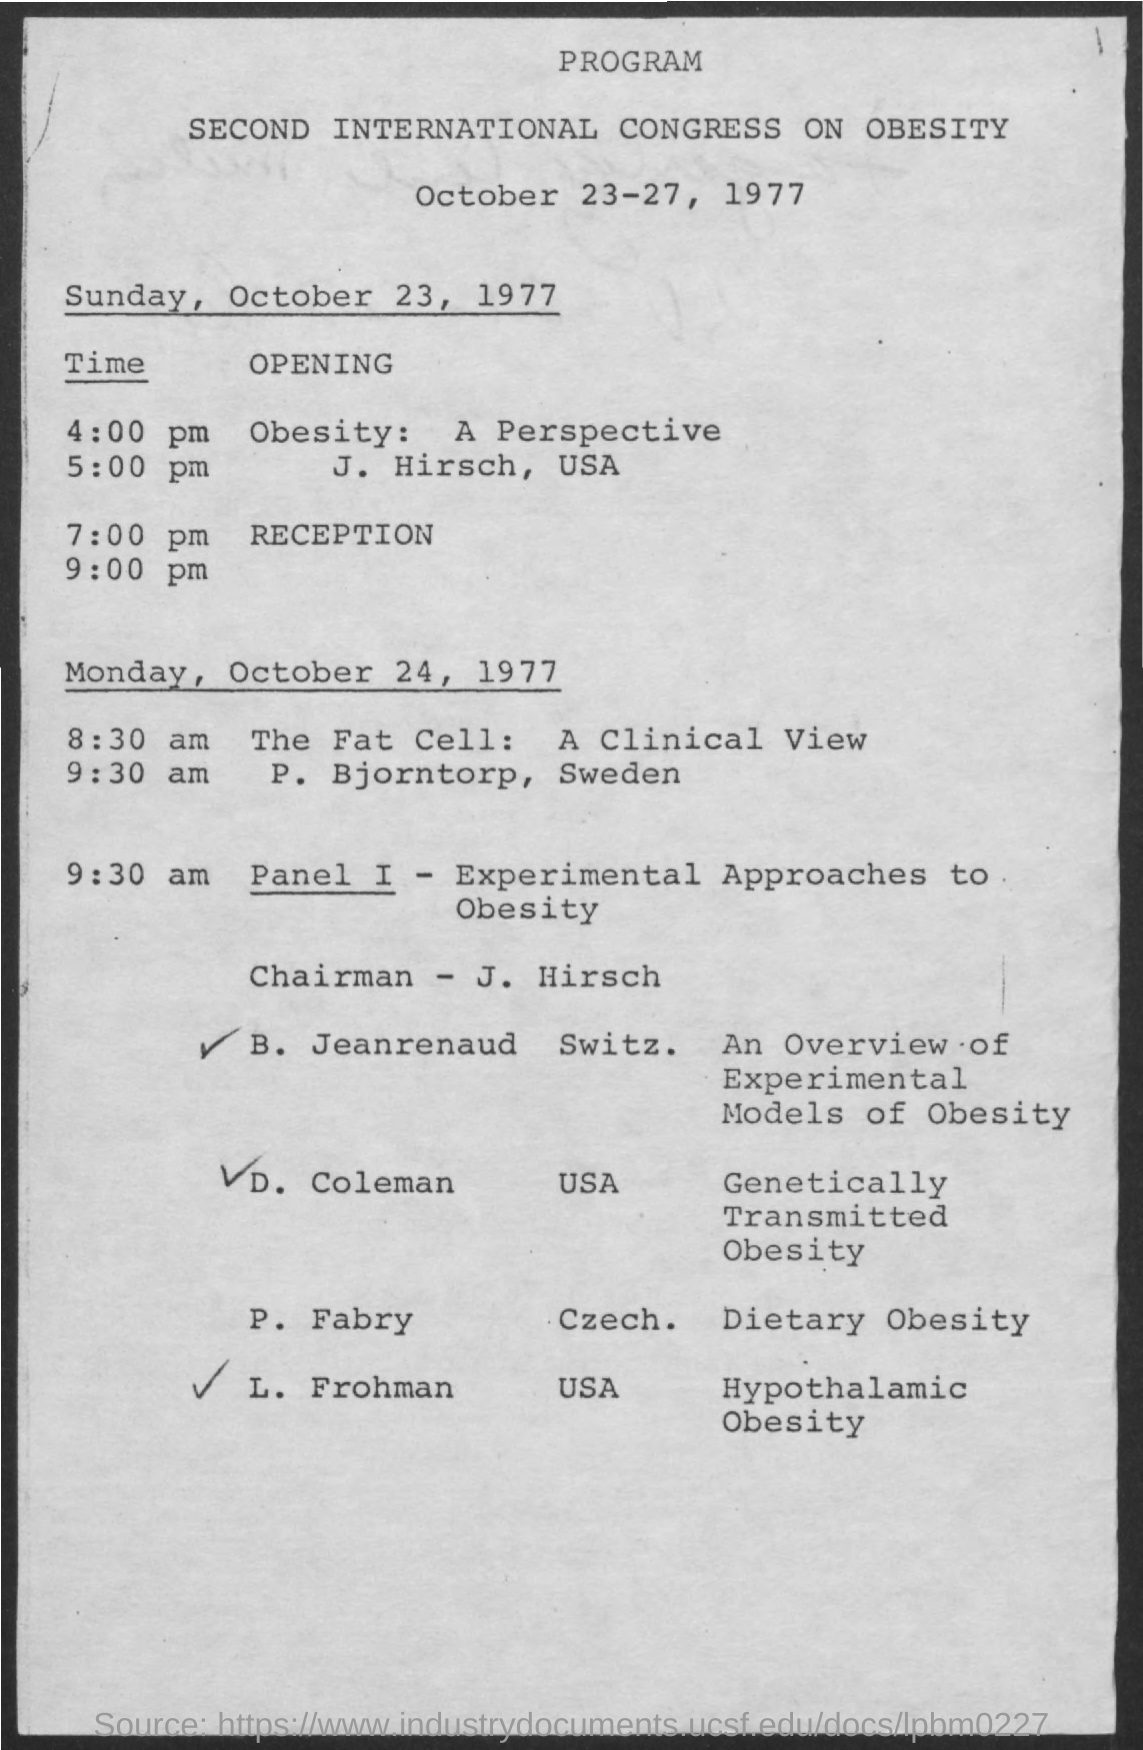Can you tell me more about the session on 'The Fat Cell: A Clinical View'? The session titled 'The Fat Cell: A Clinical View' is scheduled to be presented by P. Bjorntorp from Sweden on October 24, 1977. It focuses on the clinical aspects and implications of fat cells in medical studies and treatments of obesity. 